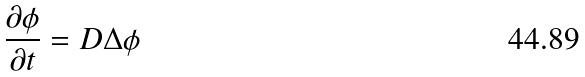Convert formula to latex. <formula><loc_0><loc_0><loc_500><loc_500>\frac { \partial \phi } { \partial t } = D \Delta \phi</formula> 